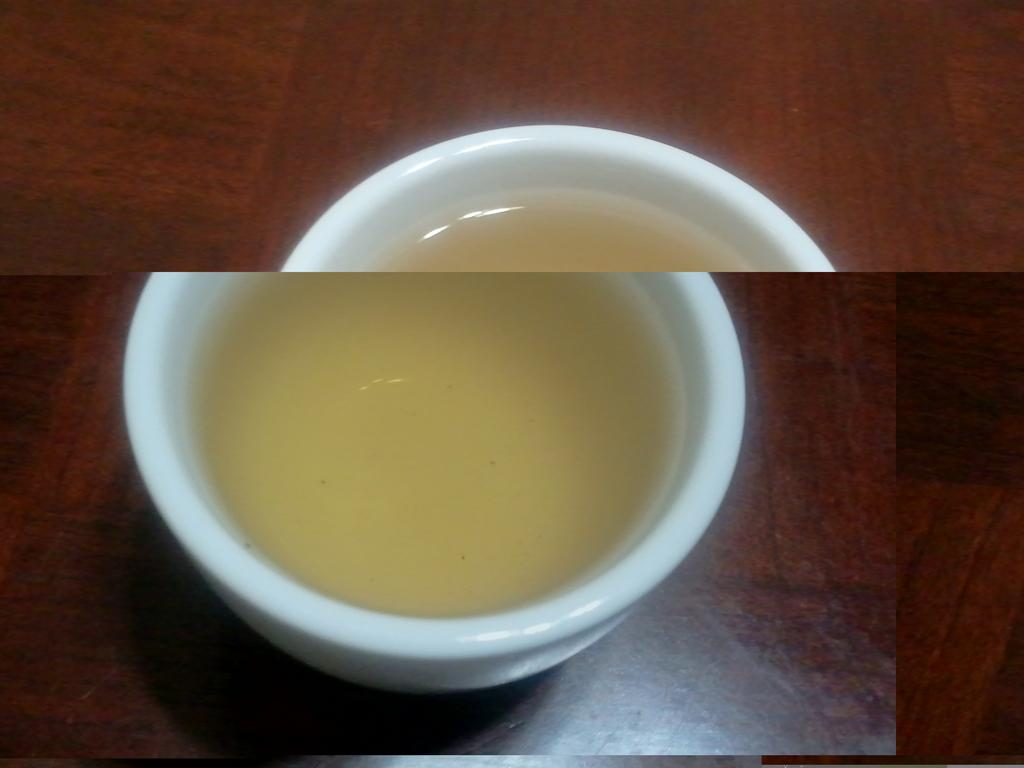What type of artwork is shown in the image? The image is a collage. What piece of furniture is visible in the image? There is a table in the image. What object is placed on the table? There is a cup on the table. What is inside the cup? There is liquid in the cup. Where is the hose connected to the elbow in the image? There is no hose or elbow present in the image. What type of farm animals can be seen in the image? There are no farm animals present in the image. 